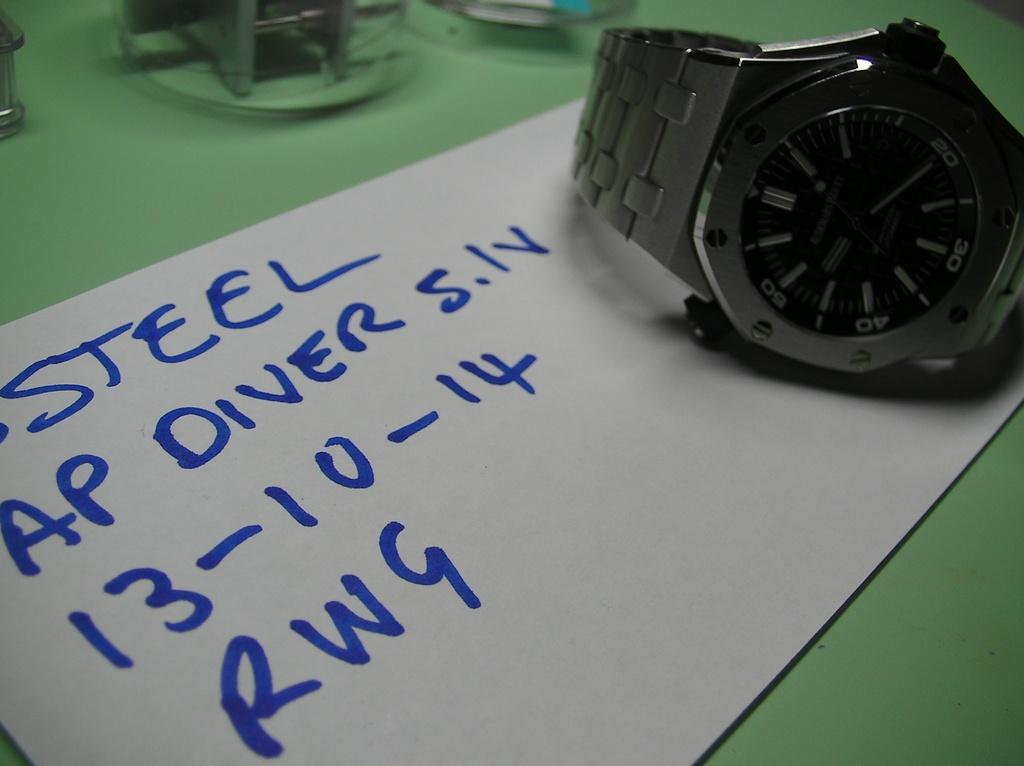<image>
Summarize the visual content of the image. A card with blue letters advertising a watch as being a steel AP DIVER. 